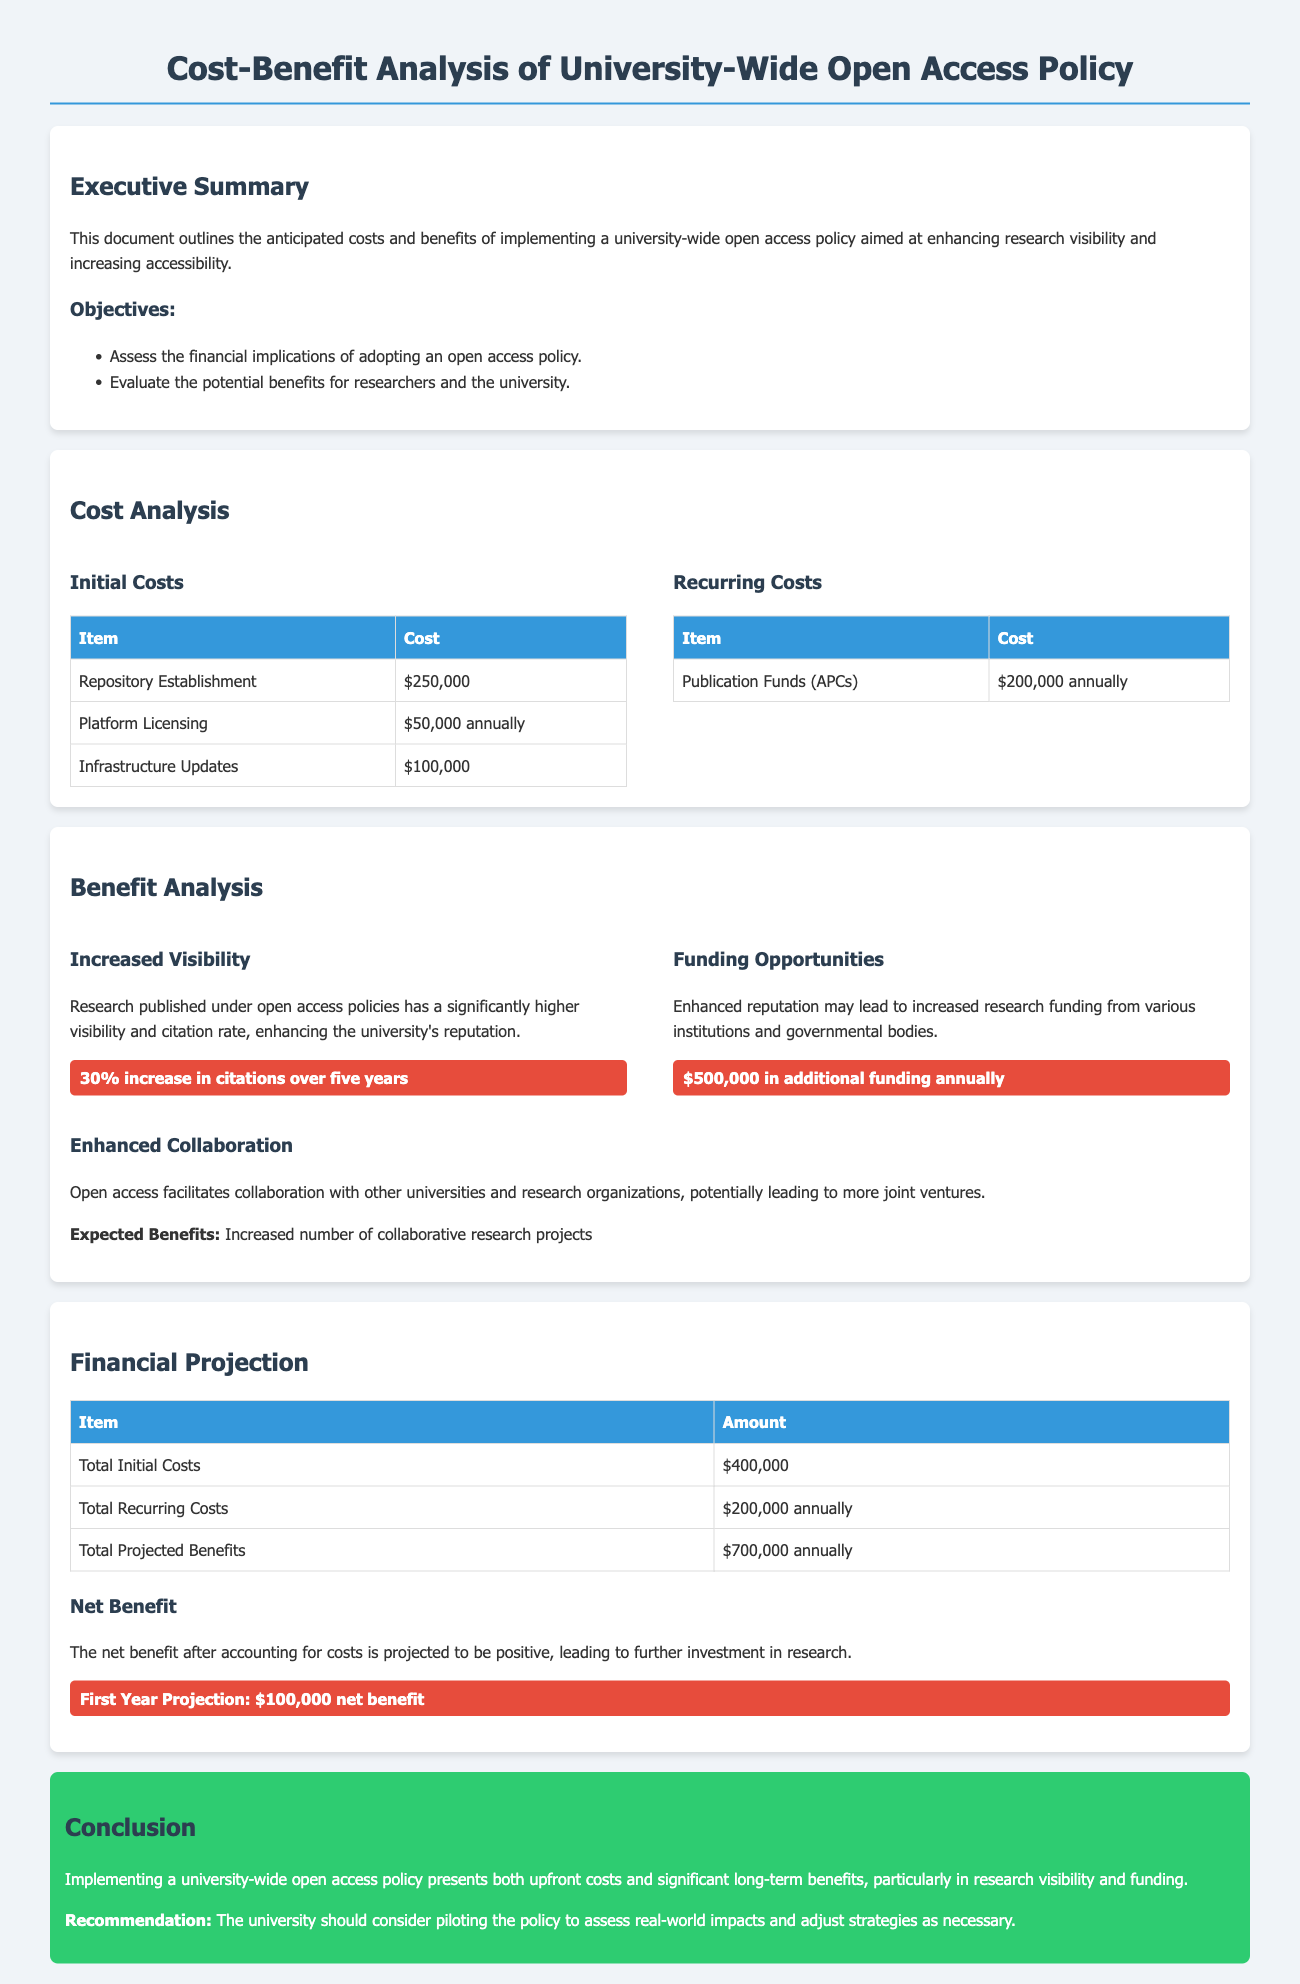what is the total initial cost? The total initial cost is listed in the Financial Projection section as the sum of all initial expenses, which includes repository establishment, platform licensing, and infrastructure updates.
Answer: $400,000 what is the annual cost for publication funds? The annual cost for publication funds is specified in the Recurring Costs table under the Cost Analysis section.
Answer: $200,000 annually how much additional funding is expected annually due to increased visibility? The additional funding expected annually due to increased visibility is mentioned in the Benefit Analysis section.
Answer: $500,000 what percentage increase in citations is projected over five years? The percentage increase in citations projected over five years is provided in the Increased Visibility subsection of the Benefit Analysis section.
Answer: 30% what is the projected net benefit in the first year? The projected net benefit in the first year is highlighted in the Financial Projection section under the Net Benefit subsection.
Answer: $100,000 net benefit what is the main recommendation from the conclusion? The main recommendation is stated in the conclusion and suggests a specific action regarding the open access policy.
Answer: pilot the policy how will the open access policy enhance collaboration? The document states the effects of open access policies on collaboration in the Benefit Analysis section.
Answer: Increased number of collaborative research projects what is one of the objectives of the analysis? One of the objectives of the analysis is mentioned in the Executive Summary section.
Answer: Assess the financial implications of adopting an open access policy 